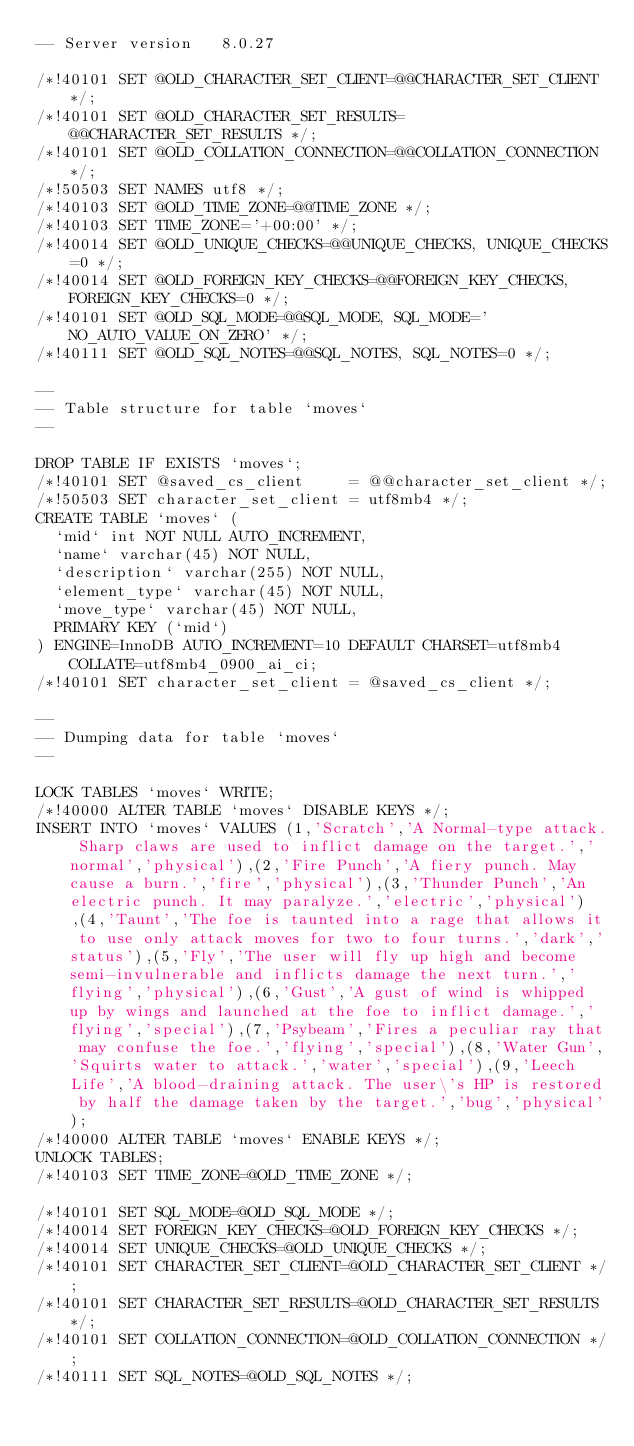Convert code to text. <code><loc_0><loc_0><loc_500><loc_500><_SQL_>-- Server version	8.0.27

/*!40101 SET @OLD_CHARACTER_SET_CLIENT=@@CHARACTER_SET_CLIENT */;
/*!40101 SET @OLD_CHARACTER_SET_RESULTS=@@CHARACTER_SET_RESULTS */;
/*!40101 SET @OLD_COLLATION_CONNECTION=@@COLLATION_CONNECTION */;
/*!50503 SET NAMES utf8 */;
/*!40103 SET @OLD_TIME_ZONE=@@TIME_ZONE */;
/*!40103 SET TIME_ZONE='+00:00' */;
/*!40014 SET @OLD_UNIQUE_CHECKS=@@UNIQUE_CHECKS, UNIQUE_CHECKS=0 */;
/*!40014 SET @OLD_FOREIGN_KEY_CHECKS=@@FOREIGN_KEY_CHECKS, FOREIGN_KEY_CHECKS=0 */;
/*!40101 SET @OLD_SQL_MODE=@@SQL_MODE, SQL_MODE='NO_AUTO_VALUE_ON_ZERO' */;
/*!40111 SET @OLD_SQL_NOTES=@@SQL_NOTES, SQL_NOTES=0 */;

--
-- Table structure for table `moves`
--

DROP TABLE IF EXISTS `moves`;
/*!40101 SET @saved_cs_client     = @@character_set_client */;
/*!50503 SET character_set_client = utf8mb4 */;
CREATE TABLE `moves` (
  `mid` int NOT NULL AUTO_INCREMENT,
  `name` varchar(45) NOT NULL,
  `description` varchar(255) NOT NULL,
  `element_type` varchar(45) NOT NULL,
  `move_type` varchar(45) NOT NULL,
  PRIMARY KEY (`mid`)
) ENGINE=InnoDB AUTO_INCREMENT=10 DEFAULT CHARSET=utf8mb4 COLLATE=utf8mb4_0900_ai_ci;
/*!40101 SET character_set_client = @saved_cs_client */;

--
-- Dumping data for table `moves`
--

LOCK TABLES `moves` WRITE;
/*!40000 ALTER TABLE `moves` DISABLE KEYS */;
INSERT INTO `moves` VALUES (1,'Scratch','A Normal-type attack. Sharp claws are used to inflict damage on the target.','normal','physical'),(2,'Fire Punch','A fiery punch. May cause a burn.','fire','physical'),(3,'Thunder Punch','An electric punch. It may paralyze.','electric','physical'),(4,'Taunt','The foe is taunted into a rage that allows it to use only attack moves for two to four turns.','dark','status'),(5,'Fly','The user will fly up high and become semi-invulnerable and inflicts damage the next turn.','flying','physical'),(6,'Gust','A gust of wind is whipped up by wings and launched at the foe to inflict damage.','flying','special'),(7,'Psybeam','Fires a peculiar ray that may confuse the foe.','flying','special'),(8,'Water Gun','Squirts water to attack.','water','special'),(9,'Leech Life','A blood-draining attack. The user\'s HP is restored by half the damage taken by the target.','bug','physical');
/*!40000 ALTER TABLE `moves` ENABLE KEYS */;
UNLOCK TABLES;
/*!40103 SET TIME_ZONE=@OLD_TIME_ZONE */;

/*!40101 SET SQL_MODE=@OLD_SQL_MODE */;
/*!40014 SET FOREIGN_KEY_CHECKS=@OLD_FOREIGN_KEY_CHECKS */;
/*!40014 SET UNIQUE_CHECKS=@OLD_UNIQUE_CHECKS */;
/*!40101 SET CHARACTER_SET_CLIENT=@OLD_CHARACTER_SET_CLIENT */;
/*!40101 SET CHARACTER_SET_RESULTS=@OLD_CHARACTER_SET_RESULTS */;
/*!40101 SET COLLATION_CONNECTION=@OLD_COLLATION_CONNECTION */;
/*!40111 SET SQL_NOTES=@OLD_SQL_NOTES */;
</code> 